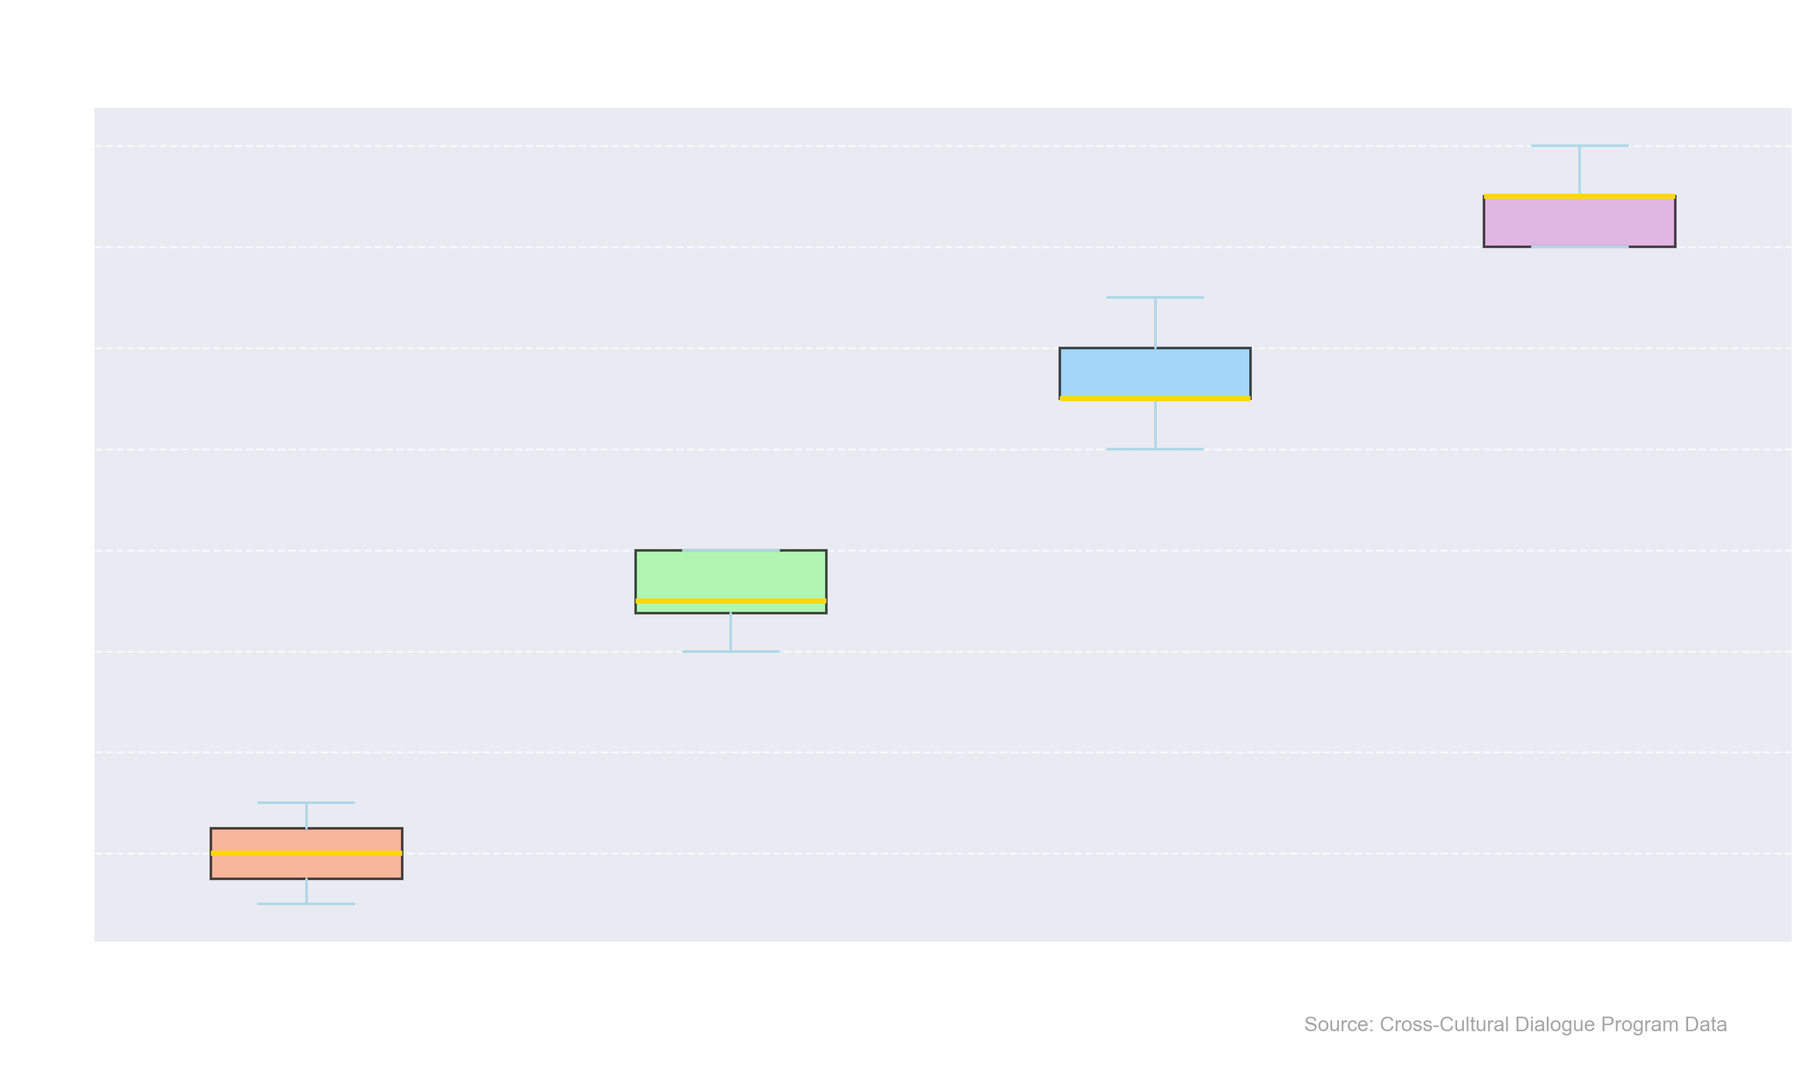What is the median years of schooling for the Elementary education level? To find the median years of schooling for the Elementary education level, look at the middle value of the sorted data points (5, 6, 7). The median is 6.
Answer: 6 How do the medians for Secondary and Higher Education compare? To compare the medians, look at the median lines inside the boxes for Secondary (11) and Higher Education (15). The median for Higher Education is greater than that for Secondary.
Answer: Higher Education > Secondary Which education level has the widest range in years of schooling? The range is determined by the distance between the minimum and maximum values (whiskers). Postgraduate has the widest range, from 18 to 20.
Answer: Postgraduate What is the interquartile range (IQR) for Secondary education? IQR is calculated by subtracting the first quartile (Q1) from the third quartile (Q3). For Secondary, Q3 is 12 and Q1 is 10, thus IQR = 12 - 10 = 2.
Answer: 2 Which education level group shows the smallest variability in years of schooling? Variability is indicated by the length of the box (IQR). Higher Education's box is smaller compared to others, indicating the least variability.
Answer: Higher Education Are there any outliers in the years of schooling for Elementary education? Outliers appear outside the whiskers. Since the whiskers extend from 5 to 7 with no points outside this range, there are no outliers in Elementary.
Answer: No What does the color of the boxes represent? Each education level has a different color for its box: Elementary (salmon), Secondary (light green), Higher Education (light blue), Postgraduate (light purple). This helps distinguish between groups.
Answer: Different colors for each education level How does the range for Higher Education compare to that of Postgraduate? Higher Education ranges from 14 to 17 (3 years), while Postgraduate ranges from 18 to 20 (2 years). The Higher Education range is slightly wider.
Answer: Higher Education > Postgraduate What is the median years of schooling for the Postgraduate education level? The median is the middle value in sorted data points. For Postgraduate, the median is the middle value between 18 and 20, which is 19.
Answer: 19 Which education level has the highest median years of schooling? Check the median line inside each box. Postgraduate has the highest median at 19 years.
Answer: Postgraduate 